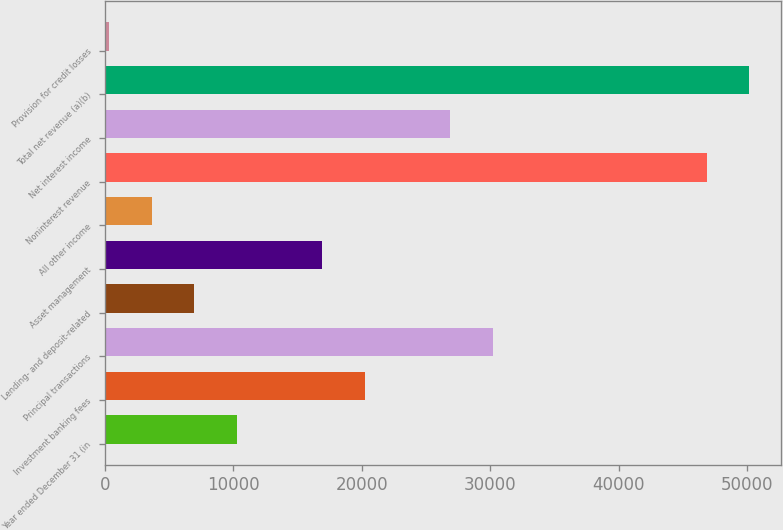<chart> <loc_0><loc_0><loc_500><loc_500><bar_chart><fcel>Year ended December 31 (in<fcel>Investment banking fees<fcel>Principal transactions<fcel>Lending- and deposit-related<fcel>Asset management<fcel>All other income<fcel>Noninterest revenue<fcel>Net interest income<fcel>Total net revenue (a)(b)<fcel>Provision for credit losses<nl><fcel>10295<fcel>20258<fcel>30221<fcel>6974<fcel>16937<fcel>3653<fcel>46826<fcel>26900<fcel>50147<fcel>332<nl></chart> 